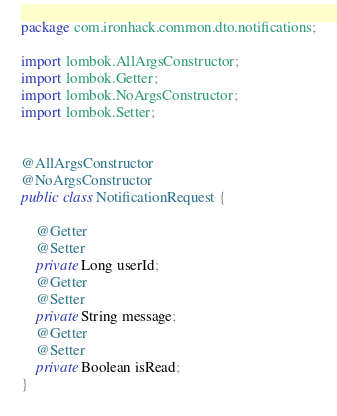Convert code to text. <code><loc_0><loc_0><loc_500><loc_500><_Java_>package com.ironhack.common.dto.notifications;

import lombok.AllArgsConstructor;
import lombok.Getter;
import lombok.NoArgsConstructor;
import lombok.Setter;


@AllArgsConstructor
@NoArgsConstructor
public class NotificationRequest {

    @Getter
    @Setter
    private Long userId;
    @Getter
    @Setter
    private String message;
    @Getter
    @Setter
    private Boolean isRead;
}
</code> 